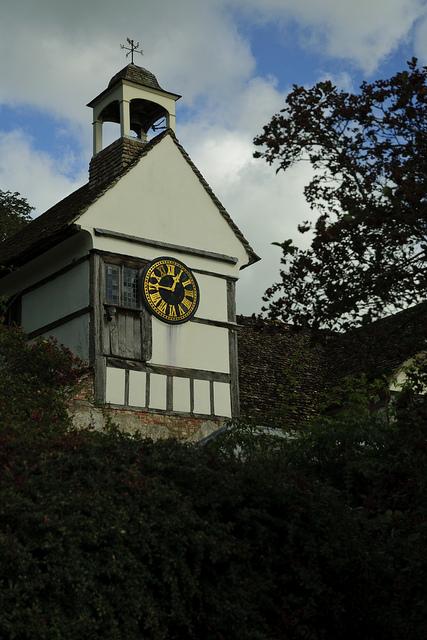In what direction is the arrow inside the green art piece pointing?
Quick response, please. Right. Is this a church?
Give a very brief answer. Yes. What time is depicted?
Concise answer only. 12:45. What time does the clock say?
Short answer required. 12:45. What time is showing on the clock?
Quick response, please. 1:45. What time does the clock have?
Short answer required. 12:46. What colors are the clock?
Be succinct. Yellow and black. 